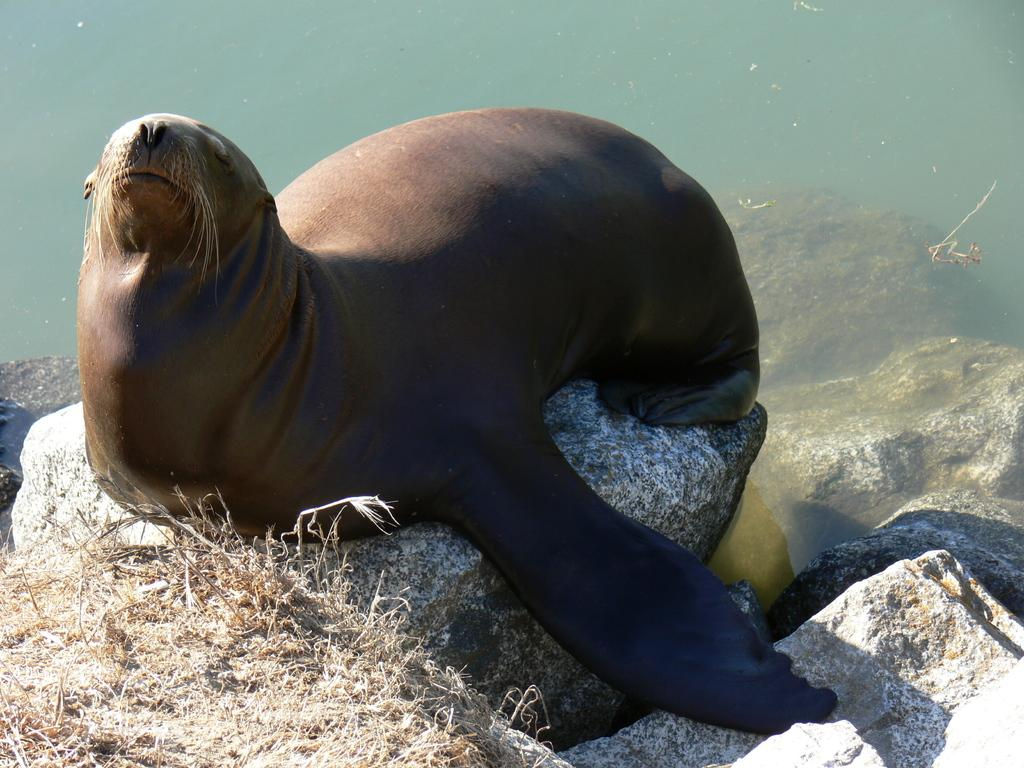What is the main subject of the image? There is an animal on a stone in the image. Can you describe the environment in the image? There is water visible in the image. What type of table can be seen in the image? There is no table present in the image. What impulse might the animal have in the image? The image does not provide information about the animal's impulses or motivations. 